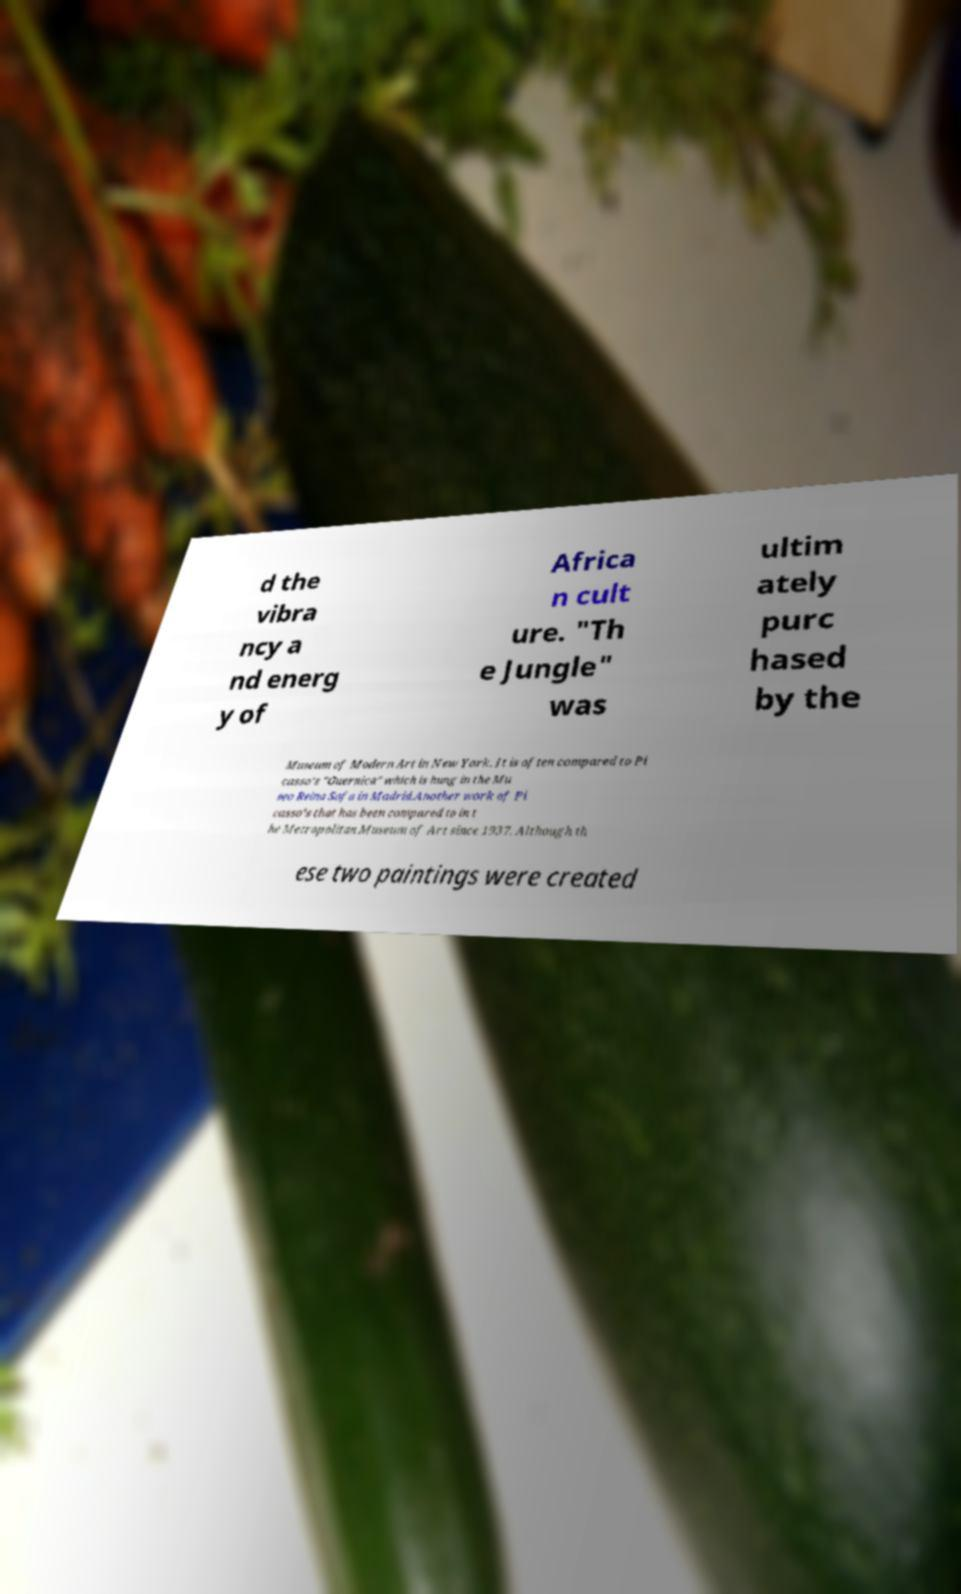Can you read and provide the text displayed in the image?This photo seems to have some interesting text. Can you extract and type it out for me? d the vibra ncy a nd energ y of Africa n cult ure. "Th e Jungle" was ultim ately purc hased by the Museum of Modern Art in New York. It is often compared to Pi casso's "Guernica" which is hung in the Mu seo Reina Sofa in Madrid.Another work of Pi casso’s that has been compared to in t he Metropolitan Museum of Art since 1937. Although th ese two paintings were created 